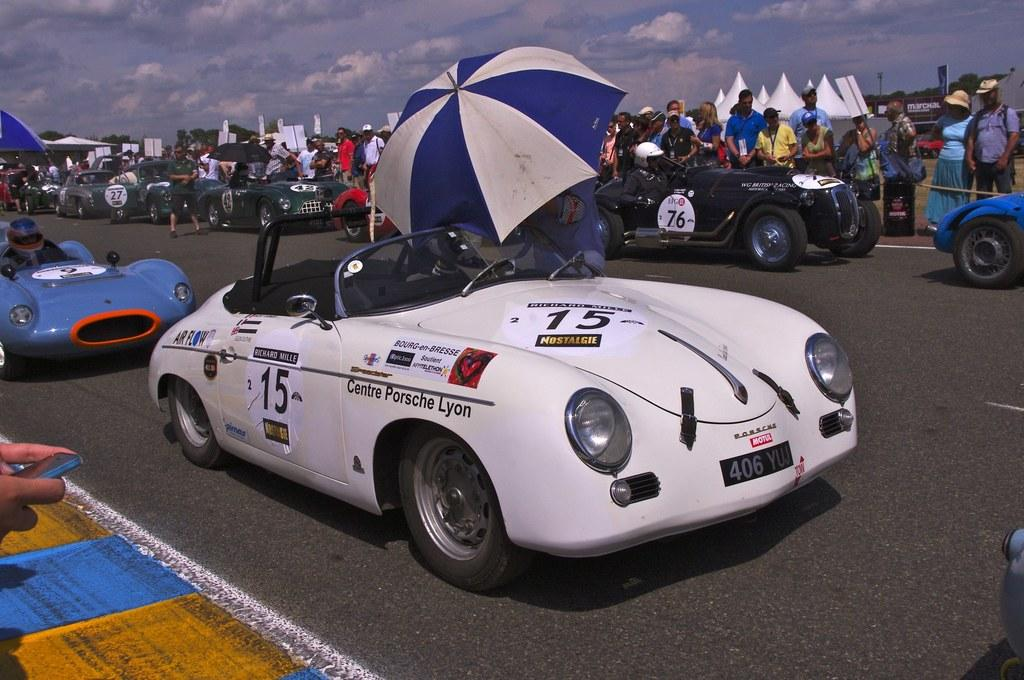What type of vehicles can be seen on the road in the image? There are cars on the road in the image. What objects are being used to protect against the weather in the image? Umbrellas are present in the image. What type of vegetation is visible in the image? Trees are visible in the image. Can you describe the people in the image? There is a group of people standing on the ground in the image. What is visible in the background of the image? The sky is visible in the background of the image. What can be seen in the sky? Clouds are present in the sky. What type of insurance is being sold by the person holding a rose in the image? There is no person holding a rose in the image, and no insurance is being sold. What liquid is being poured from the clouds in the image? There is no liquid being poured from the clouds in the image; the clouds are simply visible in the sky. 